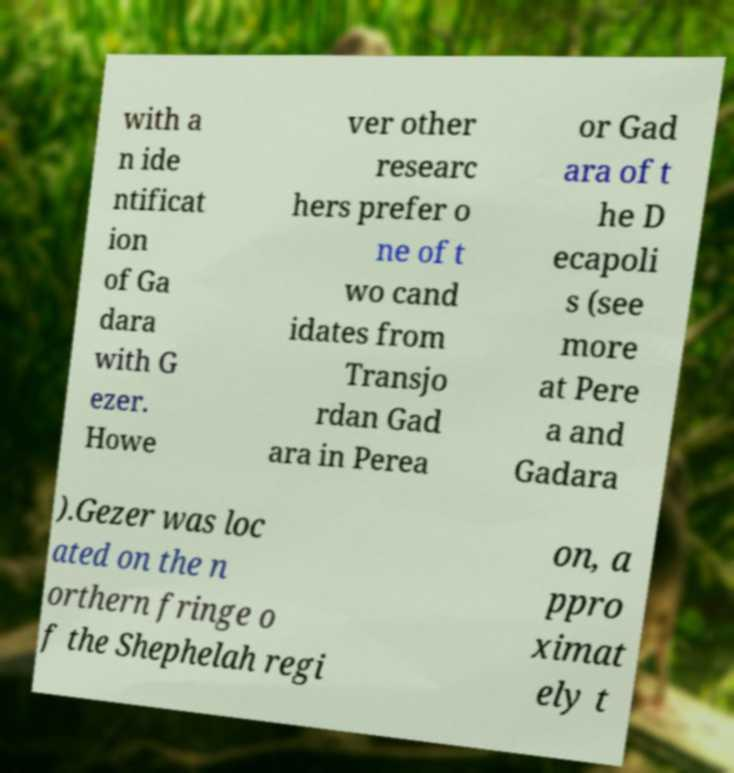What messages or text are displayed in this image? I need them in a readable, typed format. with a n ide ntificat ion of Ga dara with G ezer. Howe ver other researc hers prefer o ne of t wo cand idates from Transjo rdan Gad ara in Perea or Gad ara of t he D ecapoli s (see more at Pere a and Gadara ).Gezer was loc ated on the n orthern fringe o f the Shephelah regi on, a ppro ximat ely t 